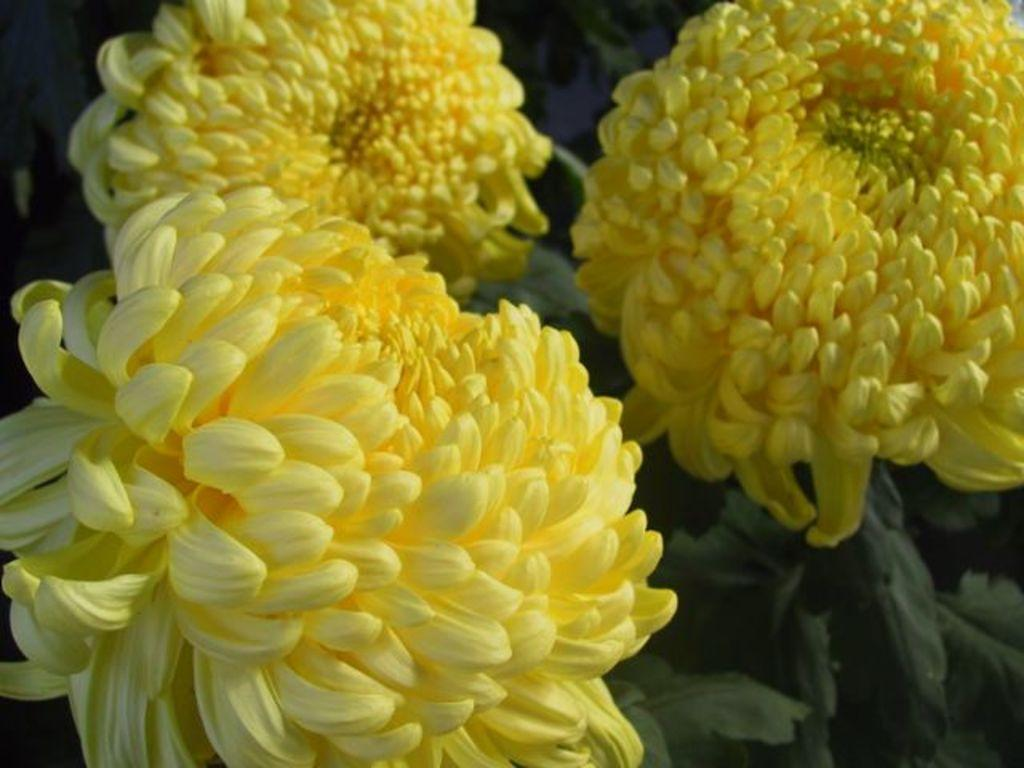What type of plants can be seen in the image? There are flowers in the image. What color are the flowers? The flowers are yellow in color. Are there any other parts of the plants visible in the image? Yes, there are leaves associated with the flowers. How many fingers can be seen holding the flowers in the image? There are no fingers or hands visible in the image; it only shows the flowers and leaves. 